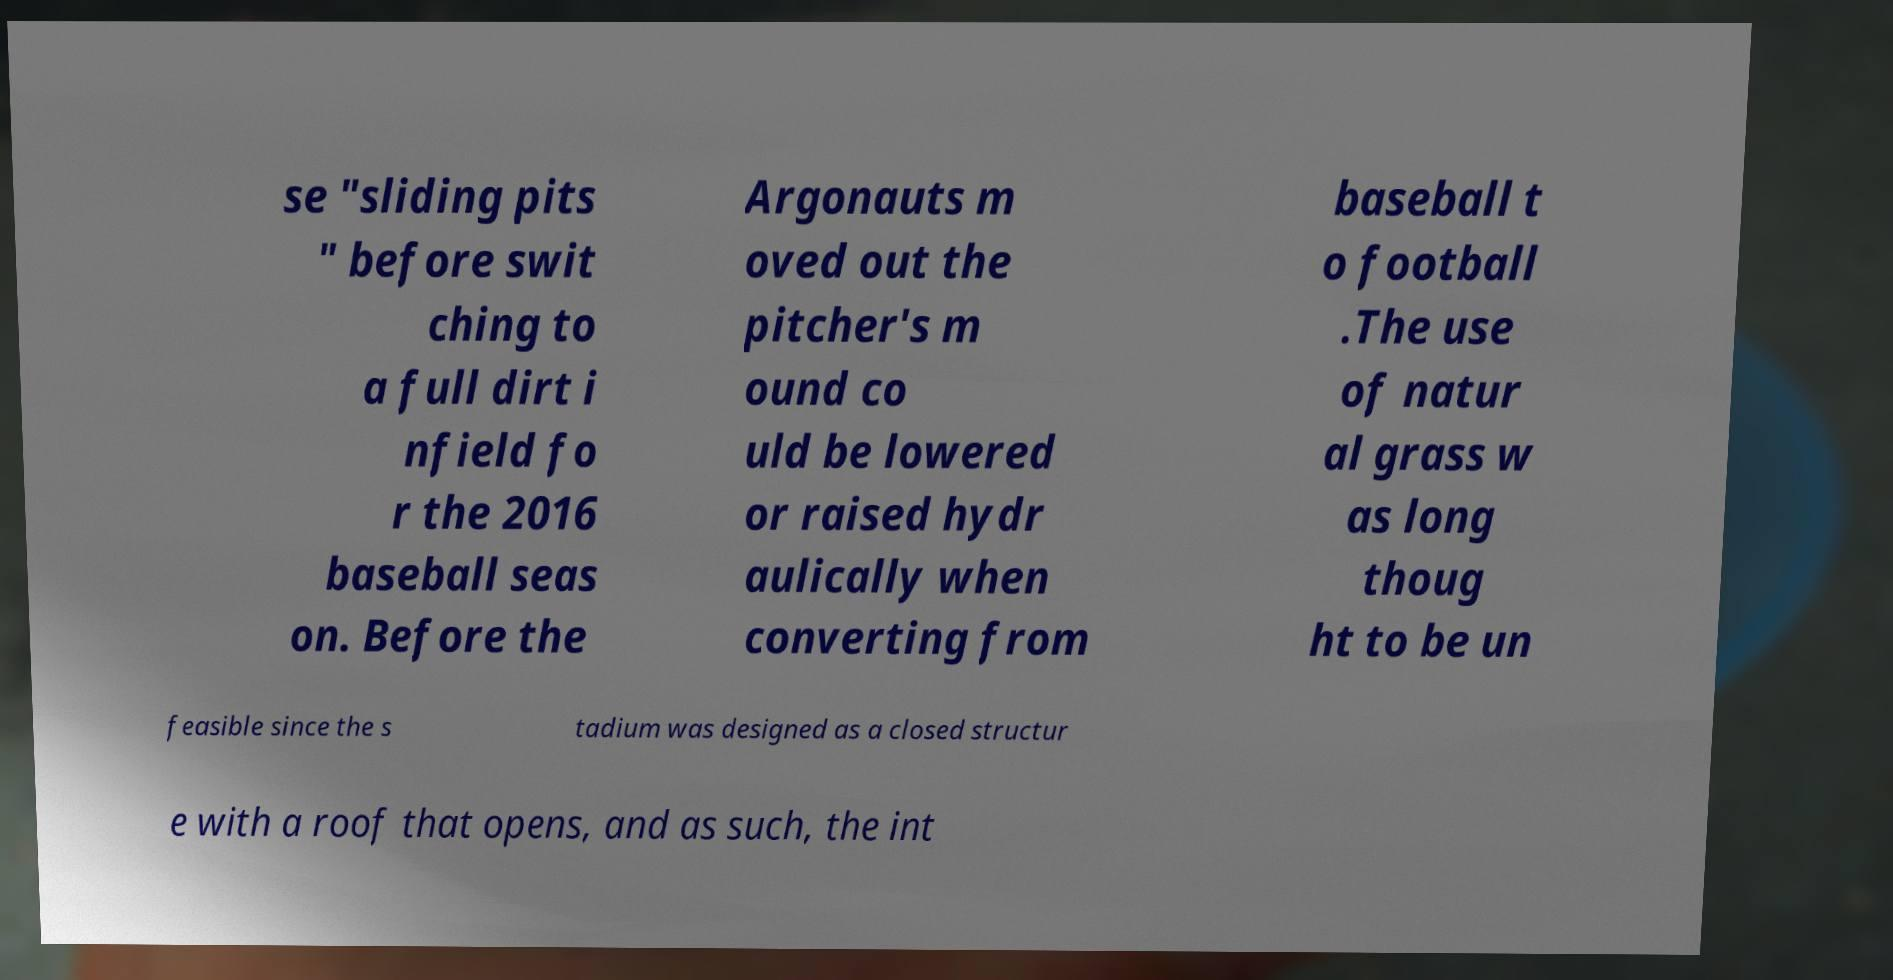There's text embedded in this image that I need extracted. Can you transcribe it verbatim? se "sliding pits " before swit ching to a full dirt i nfield fo r the 2016 baseball seas on. Before the Argonauts m oved out the pitcher's m ound co uld be lowered or raised hydr aulically when converting from baseball t o football .The use of natur al grass w as long thoug ht to be un feasible since the s tadium was designed as a closed structur e with a roof that opens, and as such, the int 